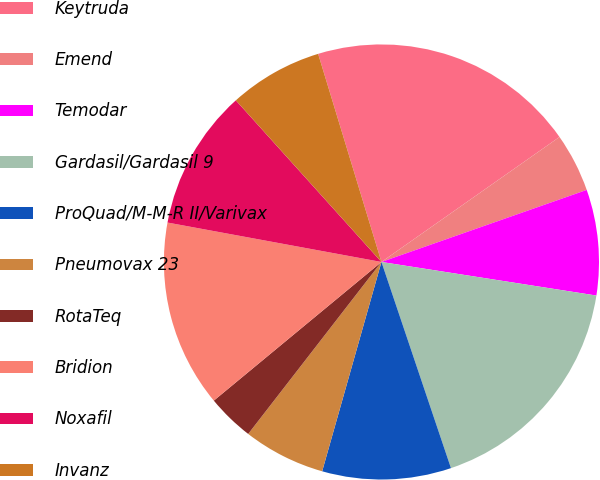<chart> <loc_0><loc_0><loc_500><loc_500><pie_chart><fcel>Keytruda<fcel>Emend<fcel>Temodar<fcel>Gardasil/Gardasil 9<fcel>ProQuad/M-M-R II/Varivax<fcel>Pneumovax 23<fcel>RotaTeq<fcel>Bridion<fcel>Noxafil<fcel>Invanz<nl><fcel>19.96%<fcel>4.37%<fcel>7.84%<fcel>17.36%<fcel>9.57%<fcel>6.1%<fcel>3.51%<fcel>13.9%<fcel>10.43%<fcel>6.97%<nl></chart> 